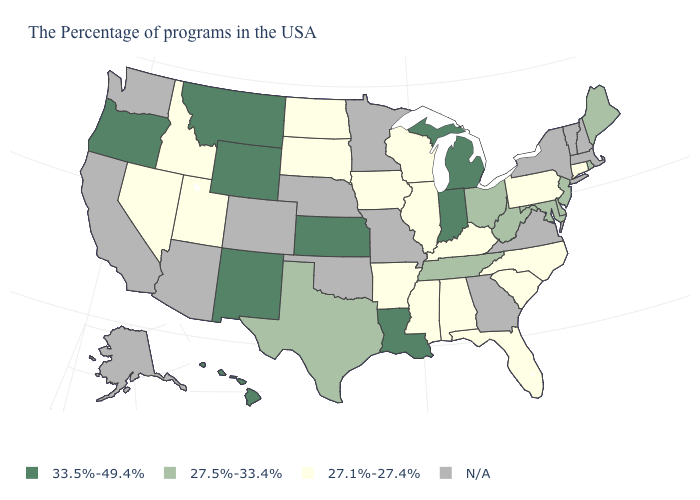What is the value of Michigan?
Concise answer only. 33.5%-49.4%. What is the value of Utah?
Quick response, please. 27.1%-27.4%. What is the value of Kansas?
Concise answer only. 33.5%-49.4%. What is the highest value in the USA?
Answer briefly. 33.5%-49.4%. How many symbols are there in the legend?
Short answer required. 4. Among the states that border Oklahoma , which have the lowest value?
Quick response, please. Arkansas. What is the value of Hawaii?
Write a very short answer. 33.5%-49.4%. What is the highest value in states that border Georgia?
Keep it brief. 27.5%-33.4%. What is the value of South Dakota?
Quick response, please. 27.1%-27.4%. Does Connecticut have the lowest value in the USA?
Write a very short answer. Yes. Does Montana have the highest value in the USA?
Answer briefly. Yes. Which states have the lowest value in the USA?
Short answer required. Connecticut, Pennsylvania, North Carolina, South Carolina, Florida, Kentucky, Alabama, Wisconsin, Illinois, Mississippi, Arkansas, Iowa, South Dakota, North Dakota, Utah, Idaho, Nevada. What is the value of Connecticut?
Be succinct. 27.1%-27.4%. Name the states that have a value in the range 27.5%-33.4%?
Keep it brief. Maine, Rhode Island, New Jersey, Delaware, Maryland, West Virginia, Ohio, Tennessee, Texas. Name the states that have a value in the range N/A?
Concise answer only. Massachusetts, New Hampshire, Vermont, New York, Virginia, Georgia, Missouri, Minnesota, Nebraska, Oklahoma, Colorado, Arizona, California, Washington, Alaska. 